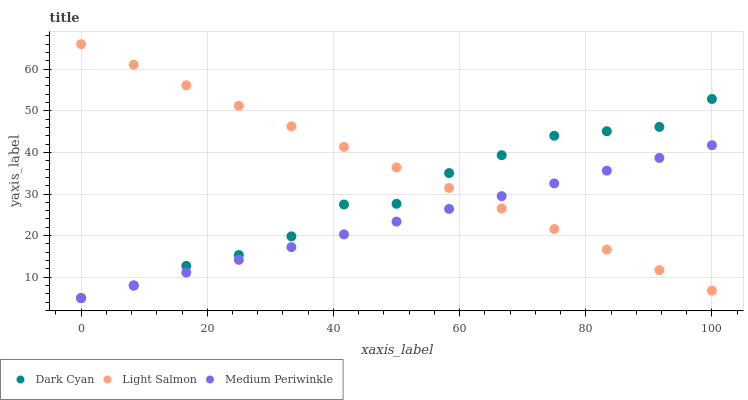Does Medium Periwinkle have the minimum area under the curve?
Answer yes or no. Yes. Does Light Salmon have the maximum area under the curve?
Answer yes or no. Yes. Does Light Salmon have the minimum area under the curve?
Answer yes or no. No. Does Medium Periwinkle have the maximum area under the curve?
Answer yes or no. No. Is Medium Periwinkle the smoothest?
Answer yes or no. Yes. Is Dark Cyan the roughest?
Answer yes or no. Yes. Is Light Salmon the smoothest?
Answer yes or no. No. Is Light Salmon the roughest?
Answer yes or no. No. Does Dark Cyan have the lowest value?
Answer yes or no. Yes. Does Light Salmon have the lowest value?
Answer yes or no. No. Does Light Salmon have the highest value?
Answer yes or no. Yes. Does Medium Periwinkle have the highest value?
Answer yes or no. No. Does Dark Cyan intersect Medium Periwinkle?
Answer yes or no. Yes. Is Dark Cyan less than Medium Periwinkle?
Answer yes or no. No. Is Dark Cyan greater than Medium Periwinkle?
Answer yes or no. No. 